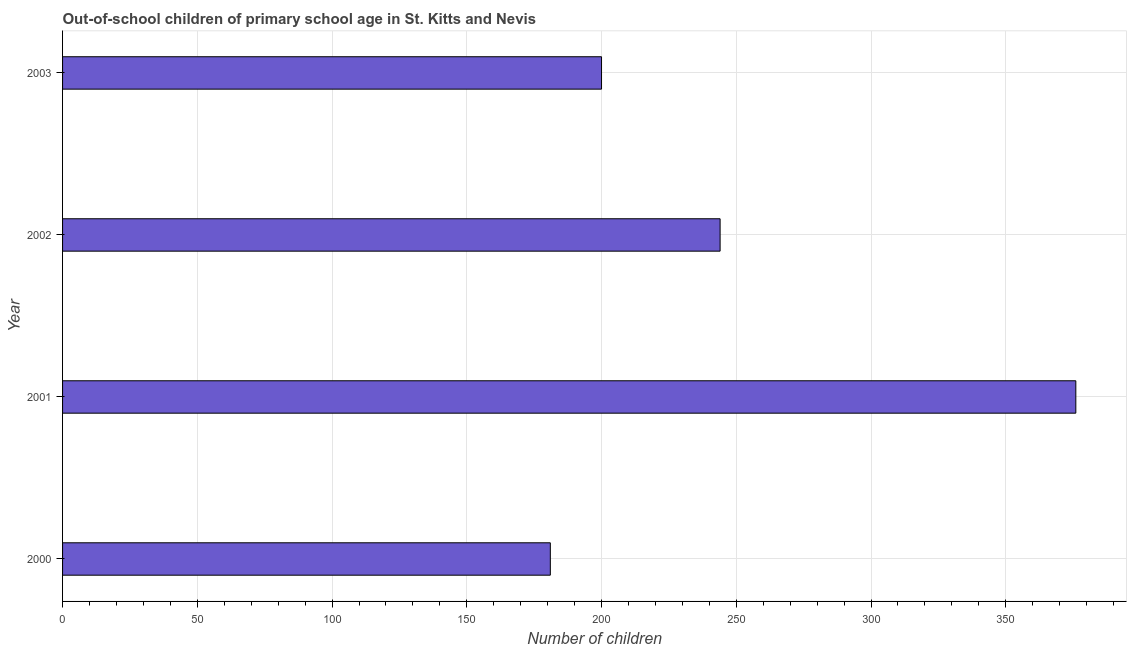Does the graph contain any zero values?
Make the answer very short. No. What is the title of the graph?
Offer a very short reply. Out-of-school children of primary school age in St. Kitts and Nevis. What is the label or title of the X-axis?
Provide a short and direct response. Number of children. What is the number of out-of-school children in 2000?
Your response must be concise. 181. Across all years, what is the maximum number of out-of-school children?
Give a very brief answer. 376. Across all years, what is the minimum number of out-of-school children?
Keep it short and to the point. 181. In which year was the number of out-of-school children maximum?
Your response must be concise. 2001. In which year was the number of out-of-school children minimum?
Your answer should be compact. 2000. What is the sum of the number of out-of-school children?
Provide a short and direct response. 1001. What is the difference between the number of out-of-school children in 2000 and 2001?
Provide a short and direct response. -195. What is the average number of out-of-school children per year?
Offer a terse response. 250. What is the median number of out-of-school children?
Your answer should be compact. 222. Do a majority of the years between 2002 and 2003 (inclusive) have number of out-of-school children greater than 240 ?
Your answer should be very brief. No. What is the ratio of the number of out-of-school children in 2000 to that in 2003?
Your response must be concise. 0.91. Is the number of out-of-school children in 2001 less than that in 2002?
Provide a succinct answer. No. Is the difference between the number of out-of-school children in 2000 and 2001 greater than the difference between any two years?
Give a very brief answer. Yes. What is the difference between the highest and the second highest number of out-of-school children?
Provide a succinct answer. 132. Is the sum of the number of out-of-school children in 2002 and 2003 greater than the maximum number of out-of-school children across all years?
Provide a succinct answer. Yes. What is the difference between the highest and the lowest number of out-of-school children?
Give a very brief answer. 195. What is the difference between two consecutive major ticks on the X-axis?
Provide a short and direct response. 50. What is the Number of children in 2000?
Your response must be concise. 181. What is the Number of children in 2001?
Keep it short and to the point. 376. What is the Number of children in 2002?
Your answer should be very brief. 244. What is the Number of children in 2003?
Your response must be concise. 200. What is the difference between the Number of children in 2000 and 2001?
Your answer should be compact. -195. What is the difference between the Number of children in 2000 and 2002?
Ensure brevity in your answer.  -63. What is the difference between the Number of children in 2000 and 2003?
Provide a succinct answer. -19. What is the difference between the Number of children in 2001 and 2002?
Give a very brief answer. 132. What is the difference between the Number of children in 2001 and 2003?
Your response must be concise. 176. What is the ratio of the Number of children in 2000 to that in 2001?
Provide a short and direct response. 0.48. What is the ratio of the Number of children in 2000 to that in 2002?
Your answer should be very brief. 0.74. What is the ratio of the Number of children in 2000 to that in 2003?
Your answer should be very brief. 0.91. What is the ratio of the Number of children in 2001 to that in 2002?
Give a very brief answer. 1.54. What is the ratio of the Number of children in 2001 to that in 2003?
Keep it short and to the point. 1.88. What is the ratio of the Number of children in 2002 to that in 2003?
Offer a very short reply. 1.22. 